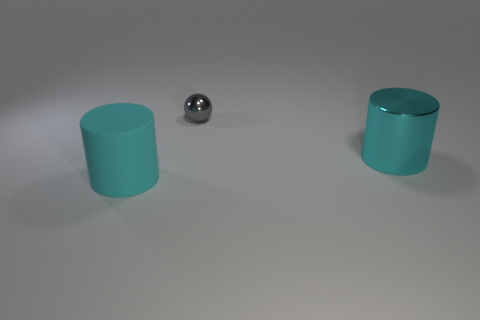Add 2 large red cylinders. How many objects exist? 5 Subtract 0 red cylinders. How many objects are left? 3 Subtract all spheres. How many objects are left? 2 Subtract 1 balls. How many balls are left? 0 Subtract all red spheres. Subtract all yellow cylinders. How many spheres are left? 1 Subtract all big cylinders. Subtract all tiny spheres. How many objects are left? 0 Add 2 cyan metallic things. How many cyan metallic things are left? 3 Add 2 tiny gray spheres. How many tiny gray spheres exist? 3 